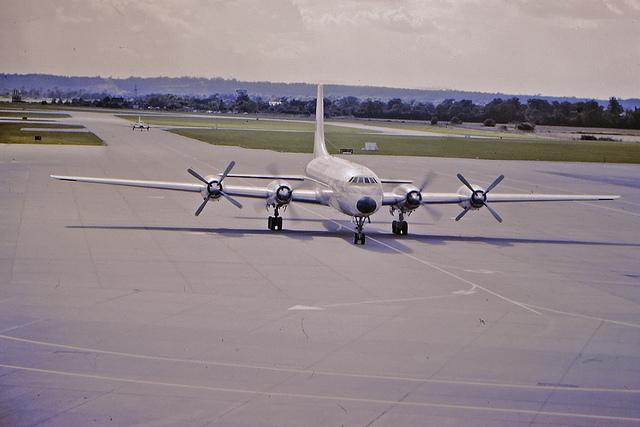Where is the vehicle located?

Choices:
A) runway
B) underground bunker
C) parking garage
D) sea runway 